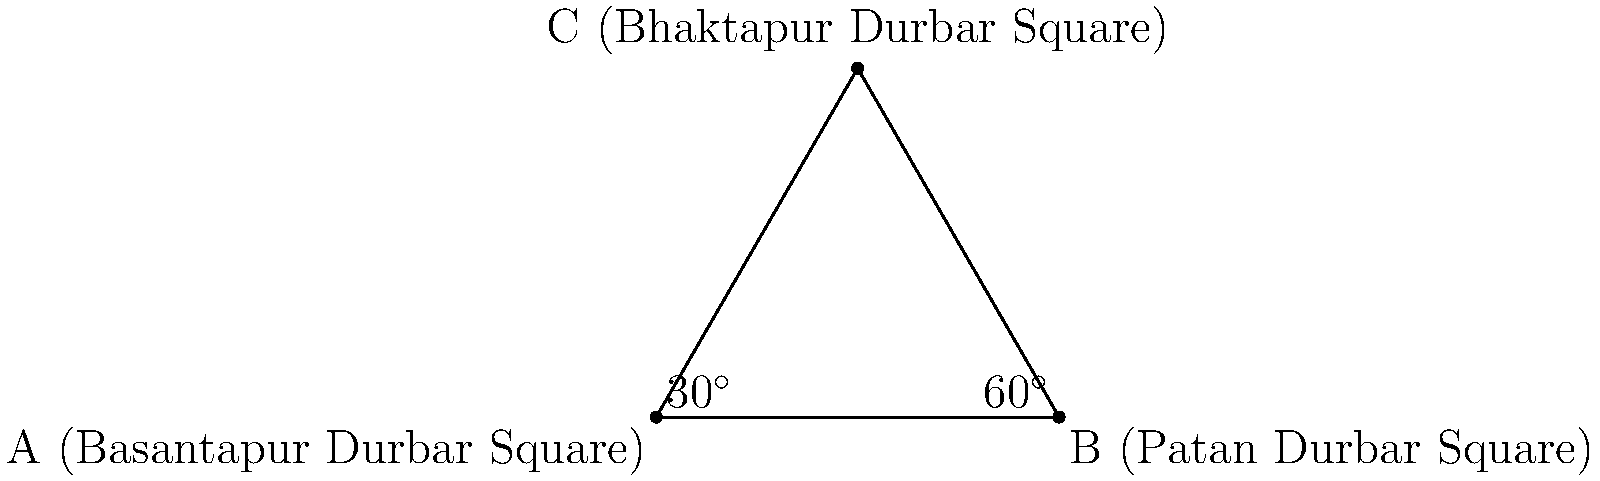In a famous Nepali film, three iconic landmarks form a triangle: Basantapur Durbar Square (A), Patan Durbar Square (B), and Bhaktapur Durbar Square (C). If the angle at Basantapur Durbar Square is $30^\circ$ and the angle at Patan Durbar Square is $60^\circ$, what is the angle at Bhaktapur Durbar Square? To solve this problem, we'll use the fact that the sum of angles in a triangle is always $180^\circ$.

Step 1: Identify the known angles
- Angle at A (Basantapur Durbar Square) = $30^\circ$
- Angle at B (Patan Durbar Square) = $60^\circ$

Step 2: Set up an equation using the sum of angles in a triangle
Let x be the angle at C (Bhaktapur Durbar Square)
$30^\circ + 60^\circ + x = 180^\circ$

Step 3: Solve for x
$90^\circ + x = 180^\circ$
$x = 180^\circ - 90^\circ$
$x = 90^\circ$

Therefore, the angle at Bhaktapur Durbar Square (C) is $90^\circ$.
Answer: $90^\circ$ 